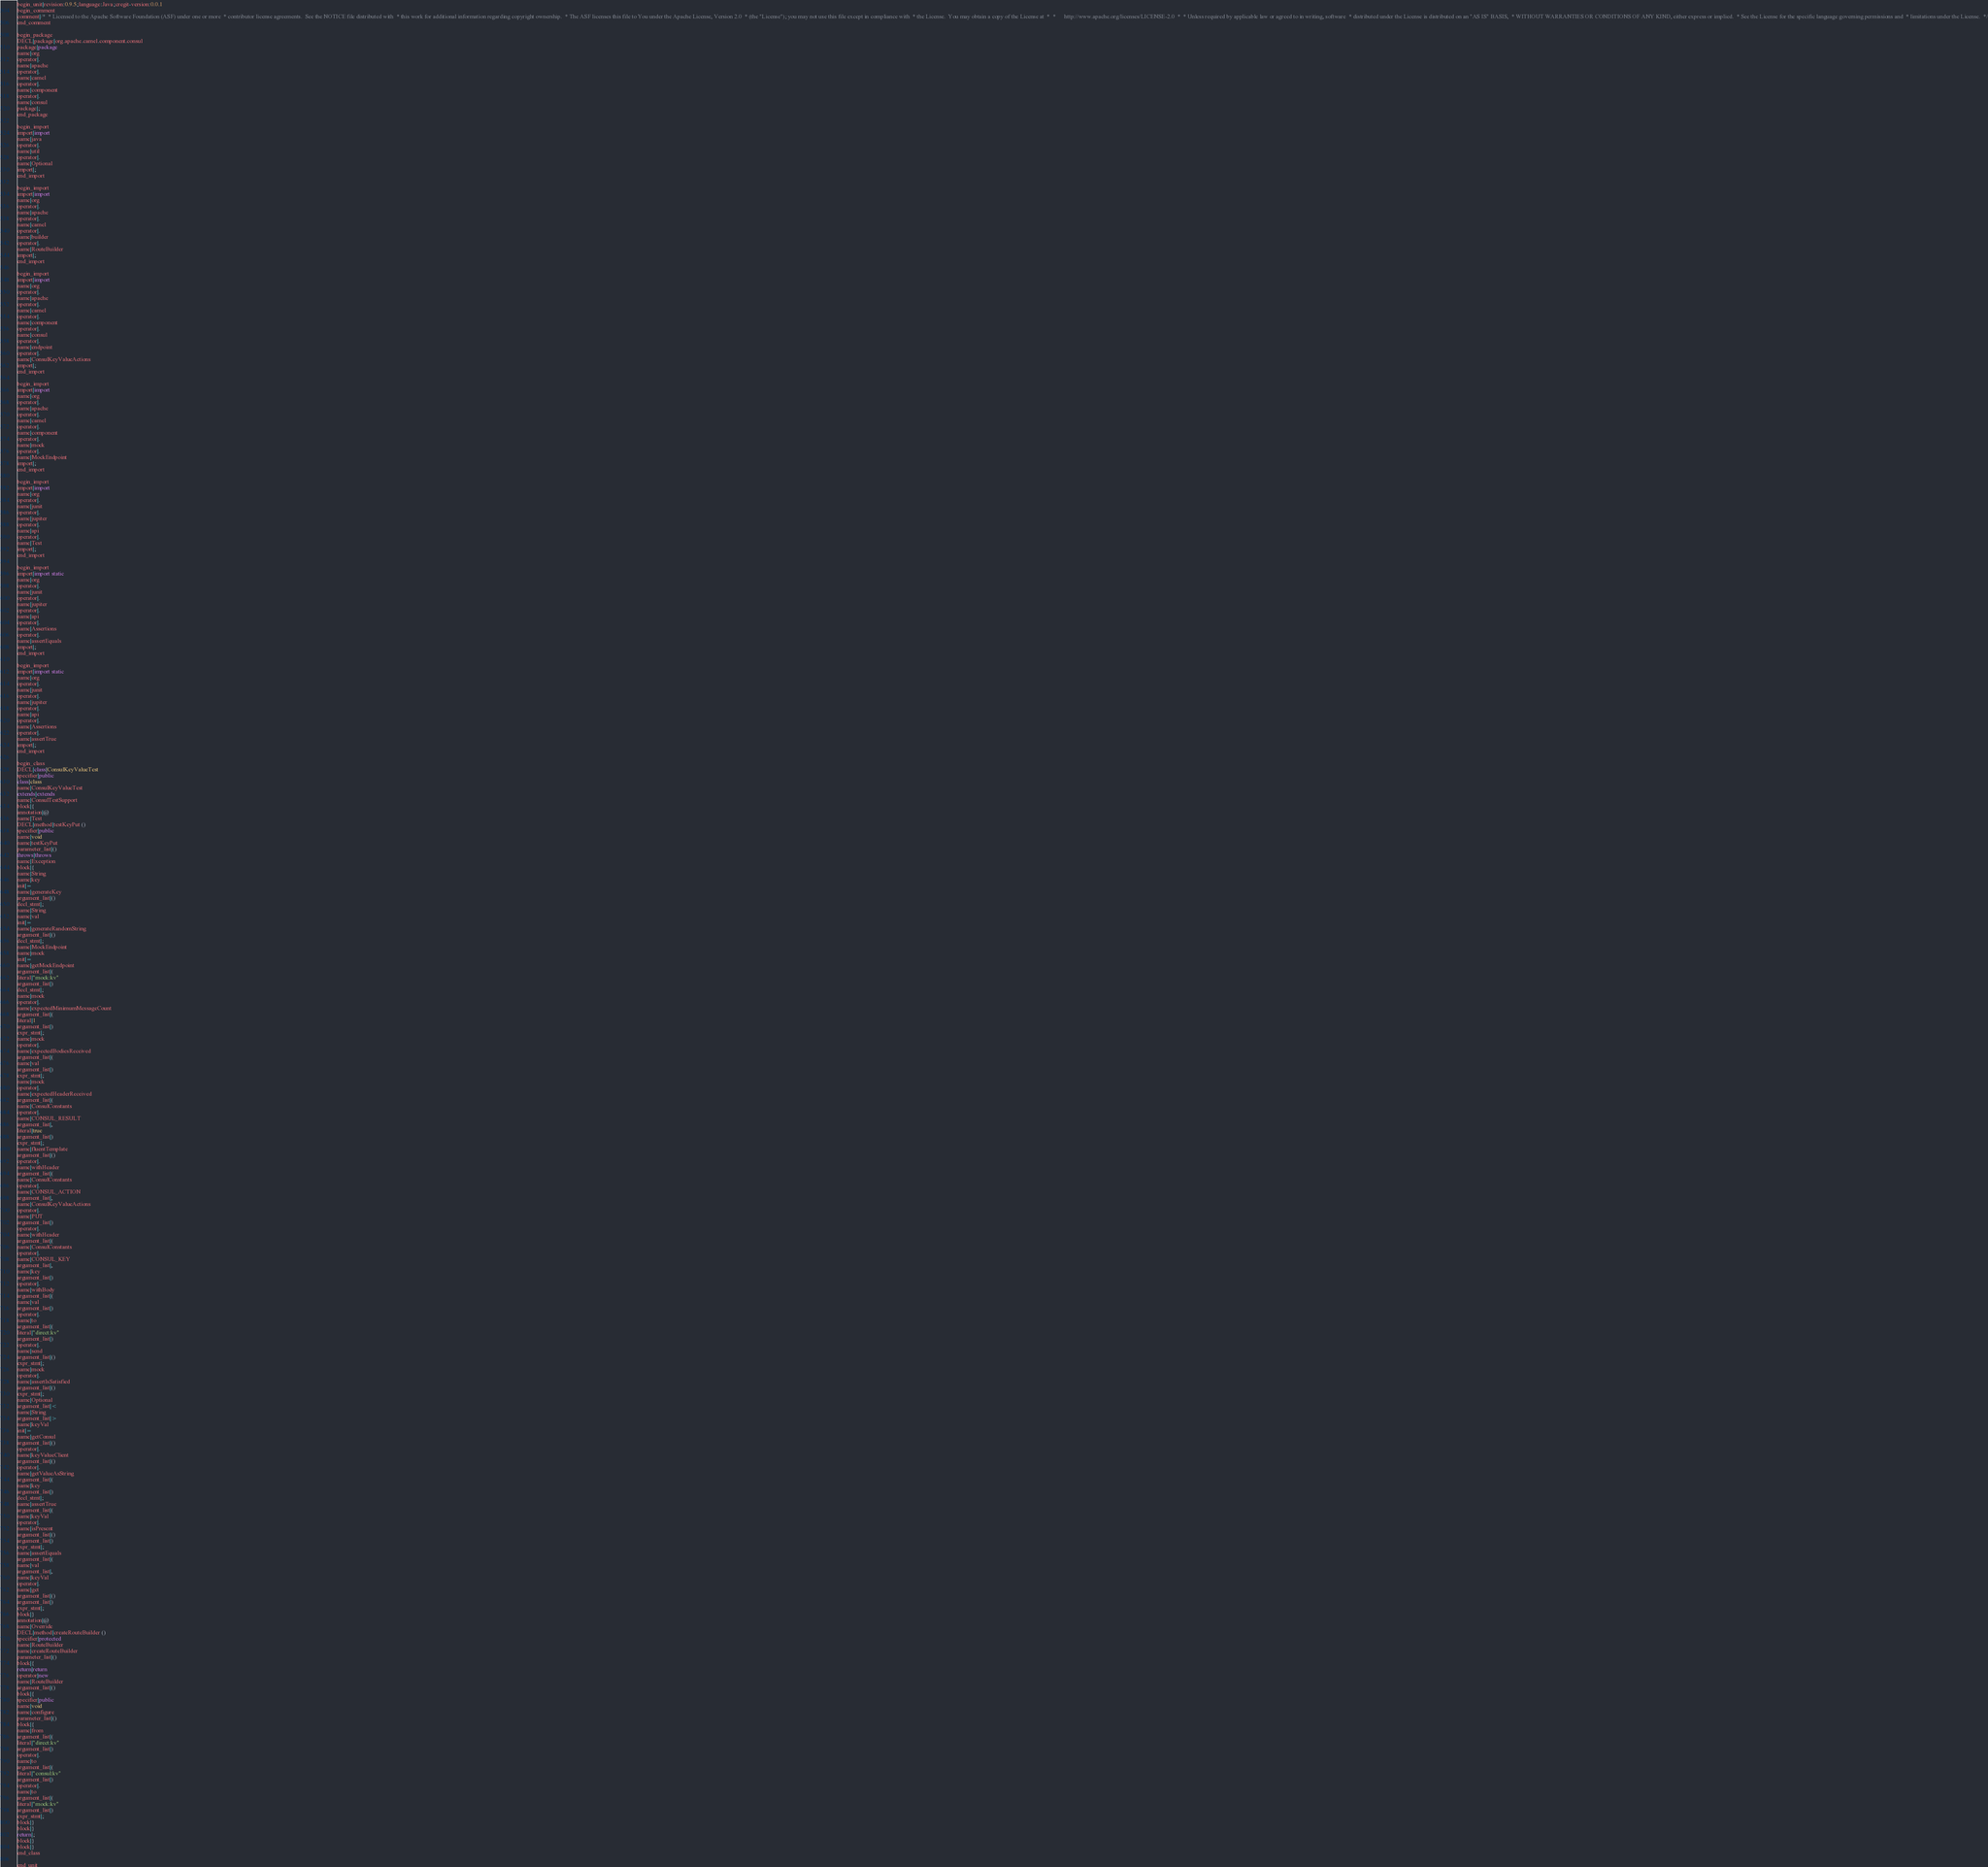Convert code to text. <code><loc_0><loc_0><loc_500><loc_500><_Java_>begin_unit|revision:0.9.5;language:Java;cregit-version:0.0.1
begin_comment
comment|/*  * Licensed to the Apache Software Foundation (ASF) under one or more  * contributor license agreements.  See the NOTICE file distributed with  * this work for additional information regarding copyright ownership.  * The ASF licenses this file to You under the Apache License, Version 2.0  * (the "License"); you may not use this file except in compliance with  * the License.  You may obtain a copy of the License at  *  *      http://www.apache.org/licenses/LICENSE-2.0  *  * Unless required by applicable law or agreed to in writing, software  * distributed under the License is distributed on an "AS IS" BASIS,  * WITHOUT WARRANTIES OR CONDITIONS OF ANY KIND, either express or implied.  * See the License for the specific language governing permissions and  * limitations under the License.  */
end_comment

begin_package
DECL|package|org.apache.camel.component.consul
package|package
name|org
operator|.
name|apache
operator|.
name|camel
operator|.
name|component
operator|.
name|consul
package|;
end_package

begin_import
import|import
name|java
operator|.
name|util
operator|.
name|Optional
import|;
end_import

begin_import
import|import
name|org
operator|.
name|apache
operator|.
name|camel
operator|.
name|builder
operator|.
name|RouteBuilder
import|;
end_import

begin_import
import|import
name|org
operator|.
name|apache
operator|.
name|camel
operator|.
name|component
operator|.
name|consul
operator|.
name|endpoint
operator|.
name|ConsulKeyValueActions
import|;
end_import

begin_import
import|import
name|org
operator|.
name|apache
operator|.
name|camel
operator|.
name|component
operator|.
name|mock
operator|.
name|MockEndpoint
import|;
end_import

begin_import
import|import
name|org
operator|.
name|junit
operator|.
name|jupiter
operator|.
name|api
operator|.
name|Test
import|;
end_import

begin_import
import|import static
name|org
operator|.
name|junit
operator|.
name|jupiter
operator|.
name|api
operator|.
name|Assertions
operator|.
name|assertEquals
import|;
end_import

begin_import
import|import static
name|org
operator|.
name|junit
operator|.
name|jupiter
operator|.
name|api
operator|.
name|Assertions
operator|.
name|assertTrue
import|;
end_import

begin_class
DECL|class|ConsulKeyValueTest
specifier|public
class|class
name|ConsulKeyValueTest
extends|extends
name|ConsulTestSupport
block|{
annotation|@
name|Test
DECL|method|testKeyPut ()
specifier|public
name|void
name|testKeyPut
parameter_list|()
throws|throws
name|Exception
block|{
name|String
name|key
init|=
name|generateKey
argument_list|()
decl_stmt|;
name|String
name|val
init|=
name|generateRandomString
argument_list|()
decl_stmt|;
name|MockEndpoint
name|mock
init|=
name|getMockEndpoint
argument_list|(
literal|"mock:kv"
argument_list|)
decl_stmt|;
name|mock
operator|.
name|expectedMinimumMessageCount
argument_list|(
literal|1
argument_list|)
expr_stmt|;
name|mock
operator|.
name|expectedBodiesReceived
argument_list|(
name|val
argument_list|)
expr_stmt|;
name|mock
operator|.
name|expectedHeaderReceived
argument_list|(
name|ConsulConstants
operator|.
name|CONSUL_RESULT
argument_list|,
literal|true
argument_list|)
expr_stmt|;
name|fluentTemplate
argument_list|()
operator|.
name|withHeader
argument_list|(
name|ConsulConstants
operator|.
name|CONSUL_ACTION
argument_list|,
name|ConsulKeyValueActions
operator|.
name|PUT
argument_list|)
operator|.
name|withHeader
argument_list|(
name|ConsulConstants
operator|.
name|CONSUL_KEY
argument_list|,
name|key
argument_list|)
operator|.
name|withBody
argument_list|(
name|val
argument_list|)
operator|.
name|to
argument_list|(
literal|"direct:kv"
argument_list|)
operator|.
name|send
argument_list|()
expr_stmt|;
name|mock
operator|.
name|assertIsSatisfied
argument_list|()
expr_stmt|;
name|Optional
argument_list|<
name|String
argument_list|>
name|keyVal
init|=
name|getConsul
argument_list|()
operator|.
name|keyValueClient
argument_list|()
operator|.
name|getValueAsString
argument_list|(
name|key
argument_list|)
decl_stmt|;
name|assertTrue
argument_list|(
name|keyVal
operator|.
name|isPresent
argument_list|()
argument_list|)
expr_stmt|;
name|assertEquals
argument_list|(
name|val
argument_list|,
name|keyVal
operator|.
name|get
argument_list|()
argument_list|)
expr_stmt|;
block|}
annotation|@
name|Override
DECL|method|createRouteBuilder ()
specifier|protected
name|RouteBuilder
name|createRouteBuilder
parameter_list|()
block|{
return|return
operator|new
name|RouteBuilder
argument_list|()
block|{
specifier|public
name|void
name|configure
parameter_list|()
block|{
name|from
argument_list|(
literal|"direct:kv"
argument_list|)
operator|.
name|to
argument_list|(
literal|"consul:kv"
argument_list|)
operator|.
name|to
argument_list|(
literal|"mock:kv"
argument_list|)
expr_stmt|;
block|}
block|}
return|;
block|}
block|}
end_class

end_unit

</code> 